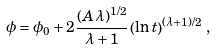Convert formula to latex. <formula><loc_0><loc_0><loc_500><loc_500>\phi = \phi _ { 0 } + 2 \frac { ( A \lambda ) ^ { 1 / 2 } } { \lambda + 1 } \left ( \ln t \right ) ^ { ( \lambda + 1 ) / 2 } \, ,</formula> 